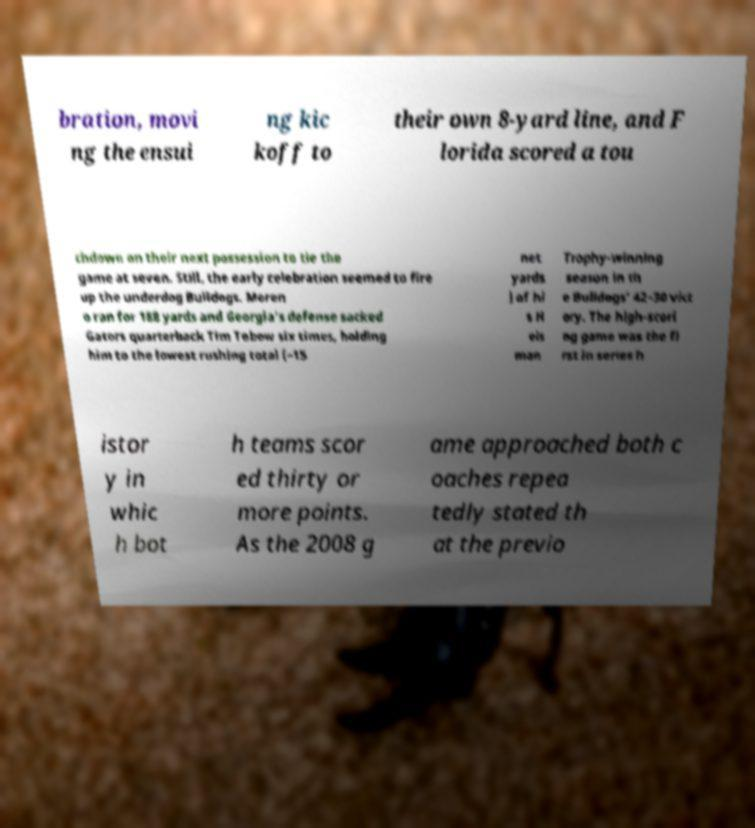Could you extract and type out the text from this image? bration, movi ng the ensui ng kic koff to their own 8-yard line, and F lorida scored a tou chdown on their next possession to tie the game at seven. Still, the early celebration seemed to fire up the underdog Bulldogs. Moren o ran for 188 yards and Georgia's defense sacked Gators quarterback Tim Tebow six times, holding him to the lowest rushing total (−15 net yards ) of hi s H eis man Trophy-winning season in th e Bulldogs' 42–30 vict ory. The high-scori ng game was the fi rst in series h istor y in whic h bot h teams scor ed thirty or more points. As the 2008 g ame approached both c oaches repea tedly stated th at the previo 